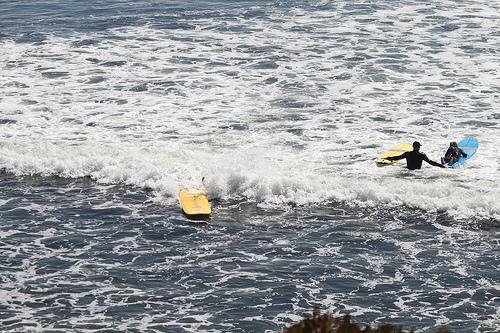What kind of clothing is the adult wearing, and what does it imply about the image's setting? The adult is wearing a wetsuit, which implies that they are in a setting involving water activities, such as surfing in the ocean. What is the primary activity taking place in the image? The primary activity depicted in the image is surfing. Can you provide a brief interpretation of the sentiment or mood of the image? The image conveys a sense of enjoyment and bonding, as a father and son share a fun surfing experience together. What is the position of the child in relation to their surfboard? The child is laying on their stomach on the surfboard. What is the relationship between the man and child in the image? The man and child appear to be father and son, both enjoying some time surfing together. What are three characteristics of the water shown in the image? The water is dark blue, wavy, and has white foamy waves. Identify and describe a notable focal point in the image. A notable focal point in the image is the father and son on surfboards, with the father wearing a wetsuit and standing on the ocean floor. List three objects present in the image. Surfboards, ocean waves, and people including a man and a child. Can you describe the appearance of the surfboards in the image? There are various surfboards, some of which are yellow, blue, or yellow and blue in color. One has a gray stripe on it. How many people can be seen in the image interacting with surfboards? There are at least two people interacting with surfboards – a man and a child. 